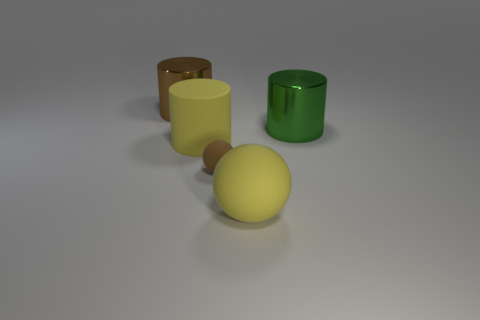Add 4 small red matte blocks. How many objects exist? 9 Subtract all cylinders. How many objects are left? 2 Add 3 purple metal cylinders. How many purple metal cylinders exist? 3 Subtract 0 green balls. How many objects are left? 5 Subtract all large yellow objects. Subtract all metallic cylinders. How many objects are left? 1 Add 1 large yellow rubber things. How many large yellow rubber things are left? 3 